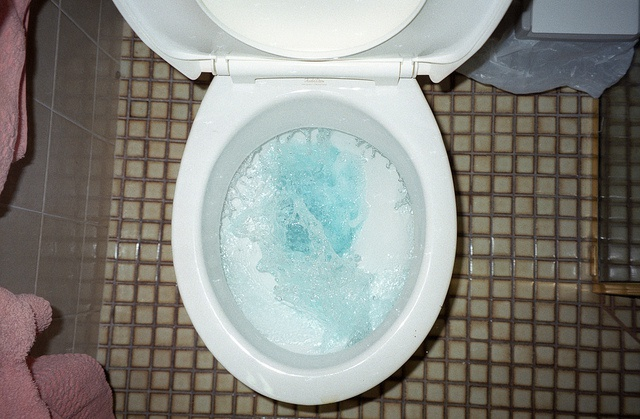Describe the objects in this image and their specific colors. I can see a toilet in black, lightgray, lightblue, and darkgray tones in this image. 